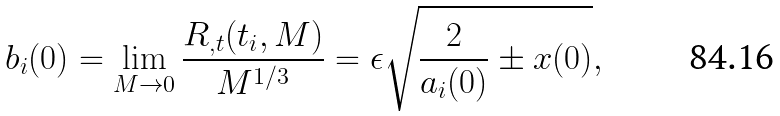Convert formula to latex. <formula><loc_0><loc_0><loc_500><loc_500>b _ { i } ( 0 ) = \lim _ { M \rightarrow 0 } \frac { R _ { , t } ( t _ { i } , M ) } { M ^ { 1 / 3 } } = \epsilon \sqrt { \frac { 2 } { a _ { i } ( 0 ) } \pm x ( 0 ) } ,</formula> 